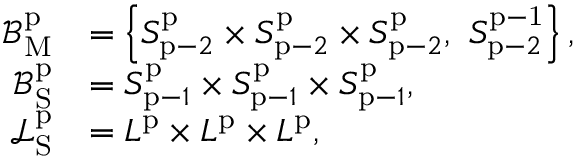Convert formula to latex. <formula><loc_0><loc_0><loc_500><loc_500>\begin{array} { r l } { \mathcal { B } _ { M } ^ { p } } & { = \left \{ S _ { p - 2 } ^ { p } \times S _ { p - 2 } ^ { p } \times S _ { p - 2 } ^ { p } , \ S _ { p - 2 } ^ { p - 1 } \right \} , } \\ { \mathcal { B } _ { S } ^ { p } } & { = S _ { p - 1 } ^ { p } \times S _ { p - 1 } ^ { p } \times S _ { p - 1 } ^ { p } , } \\ { \mathcal { L } _ { S } ^ { p } } & { = L ^ { p } \times L ^ { p } \times L ^ { p } , } \end{array}</formula> 